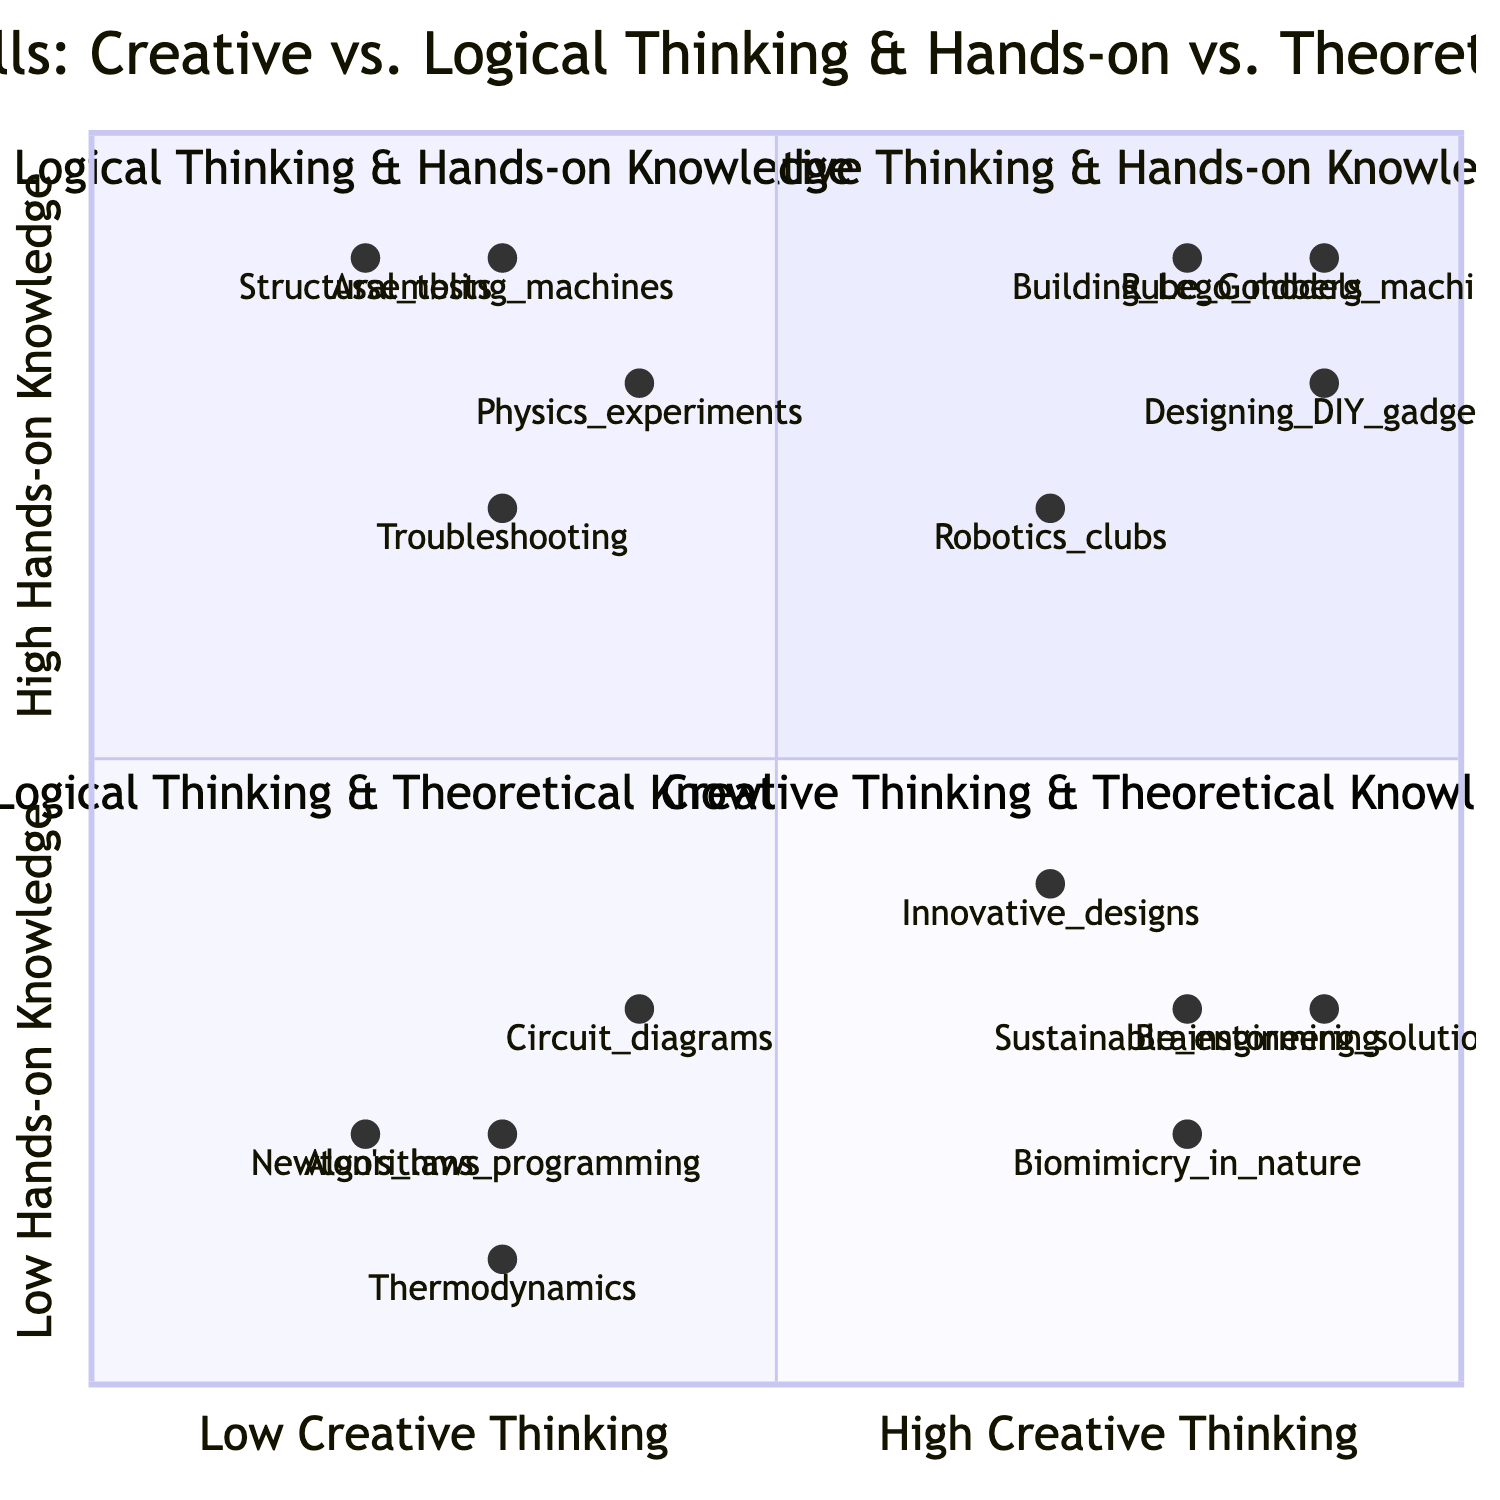What is located in the "Creative Thinking & Hands-on Knowledge" quadrant? In the "Creative Thinking & Hands-on Knowledge" quadrant, the skills listed are activities where both creative thinking and hands-on knowledge are applied. According to the data, these skills include building Lego models, designing DIY gadgets, participating in robotics clubs, and building Rube Goldberg machines.
Answer: Building Lego models, designing DIY gadgets, participating in robotics clubs, building Rube Goldberg machines Which skill has the highest logical thinking and hands-on knowledge score? By examining the provided coordinates, the skill that demonstrates the highest level of logical thinking while possessing significant hands-on knowledge is "Assembling machines" with a score of 0.3 in creative thinking and 0.9 in hands-on knowledge. This indicates its placement in the quadrant relevant to this inquiry.
Answer: Assembling machines How many skills are categorized under "Logical Thinking & Theoretical Knowledge"? By reviewing the data provided for the quadrant labeled "Logical Thinking & Theoretical Knowledge", I can identify that there are four distinct skills presented: learning about Newton's laws of motion, understanding thermodynamics principles, studying circuit diagrams, and learning about algorithms and programming concepts. Thus, this totals to four skills.
Answer: 4 What is the score for "Brainstorming inventive solutions"? The data indicates that "Brainstorming inventive solutions" has a score of 0.9 in creative thinking and 0.3 in hands-on knowledge. The specific score for this skill falls under the aspect of creative thinking.
Answer: 0.9 Which skill demonstrates the highest theoretical knowledge score? On analyzing the skills in the "Logical Thinking & Theoretical Knowledge" quadrant, "Learning about Newton's laws of motion" has the highest score of 0.2 on both logical thinking and theoretical knowledge, indicating it showcases substantial theoretical knowledge.
Answer: Learning about Newton's laws of motion What is the relationship between "Conducting physics experiments" and "Troubleshooting mechanical problems"? The skill "Conducting physics experiments" is placed in the quadrant of logical thinking and hands-on knowledge, with corresponding coordinates of [0.4, 0.8]. "Troubleshooting mechanical problems" shares a similar quadrant location but has slightly different scores. Both fall into the category of logical thinking and hands-on knowledge but differ in their specific scores.
Answer: They both fall into logical thinking and hands-on knowledge How many skills exhibit high creative thinking? "High" creative thinking is quantified as a score of above 0.7 in the designated quadrant. Evaluating skills such as building Lego models, designing DIY gadgets, Rube Goldberg machines, and brainstorming inventive solutions confirms that there are four skills achieving this criteria.
Answer: 4 What is the score for "Understanding thermodynamics principles"? The score assigned to "Understanding thermodynamics principles" is registered in the dataset as 0.3 for logical thinking and 0.1 for theoretical knowledge.
Answer: 0.3 